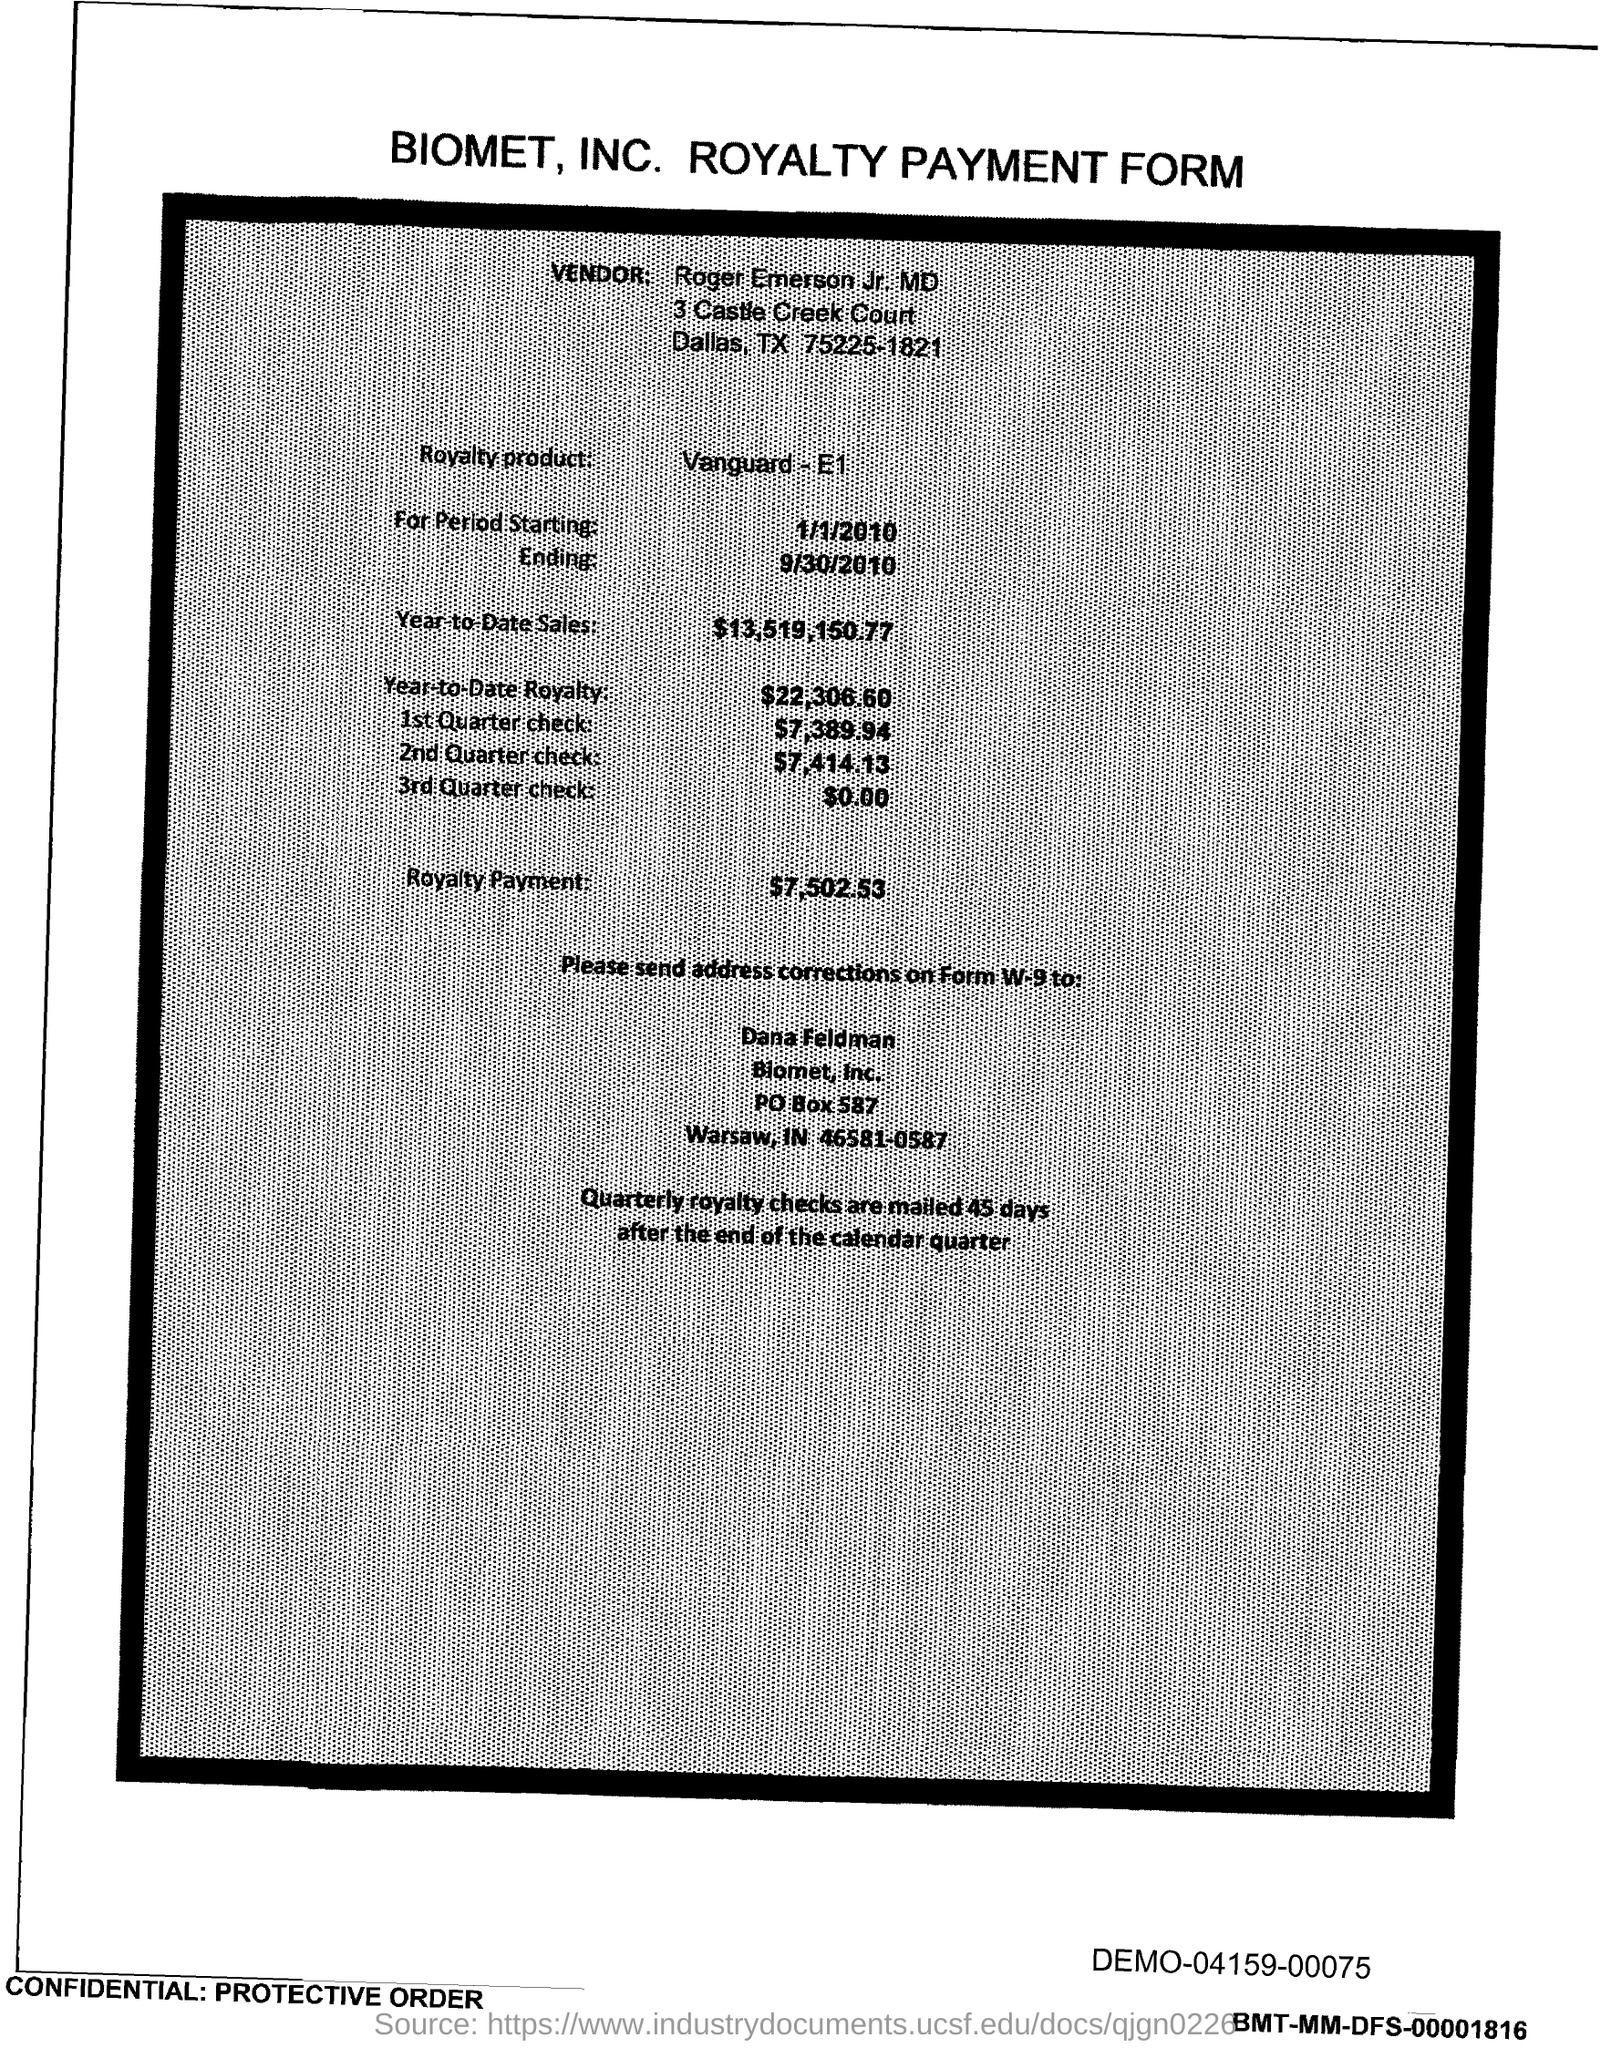Identify some key points in this picture. The royalty period began on January 1, 2010. The royalty payment for the product mentioned in the form is $7,502.53. The year-to-date royalty for the product is $22,306.60. The amount mentioned in the 2nd Quarter check form is $7,414.13. The royalty product, in the form of Vanguard E1, is what is being referred to in this conversation. 